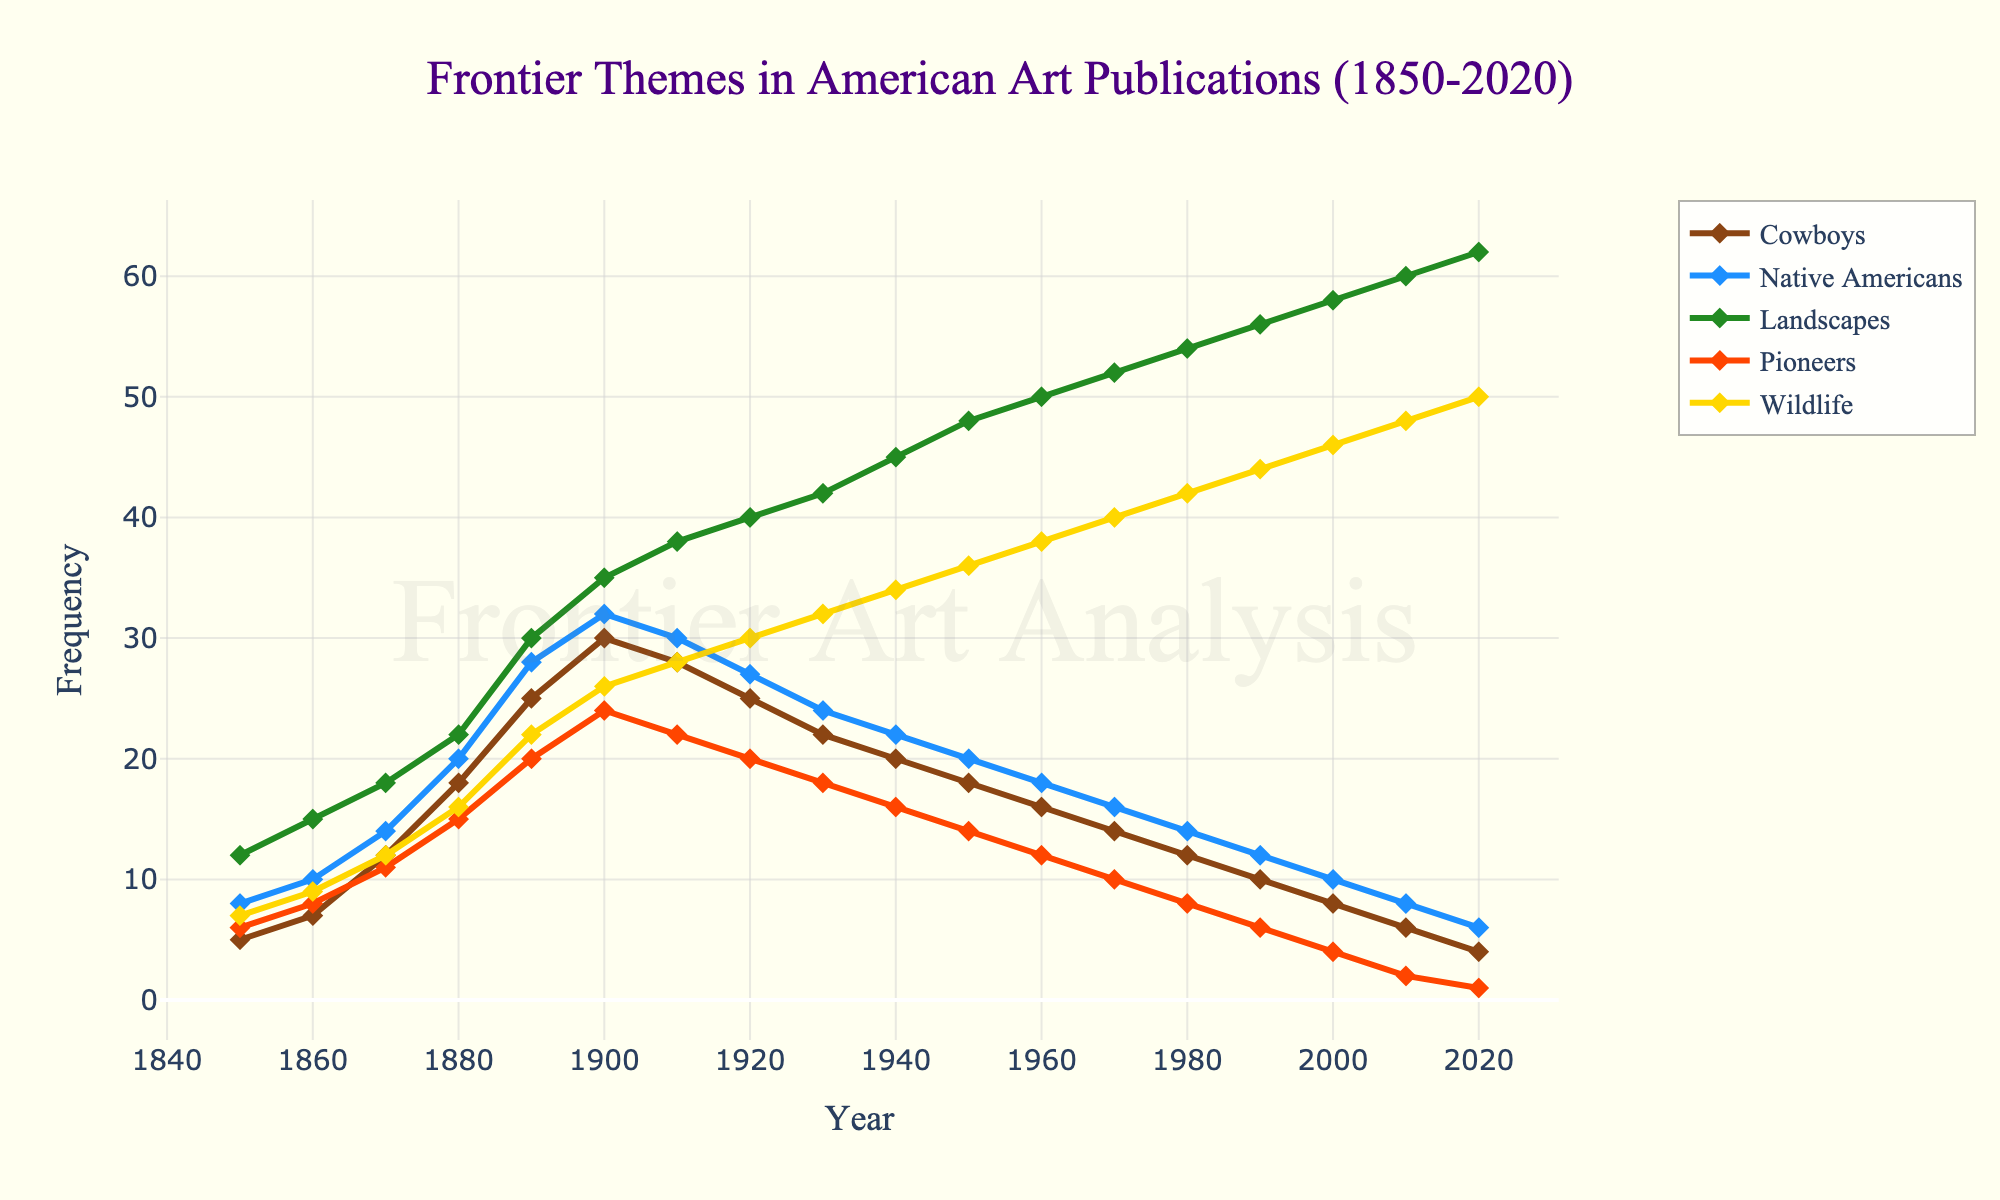Which theme had the highest frequency in 1920? In 1920, the frequency of each theme is represented visually on the line chart by their respective heights. By observing the chart, we can see that "Landscapes" has the highest point in 1920.
Answer: Landscapes How did the frequency of the "Cowboys" theme change from 1850 to 1880? To find the change in frequency, we need to subtract the frequency in 1850 from the frequency in 1880 for the "Cowboys" theme. In 1850, it was 5, and in 1880, it was 18. So, the change is 18 - 5.
Answer: Increase of 13 Which theme showed the most consistent increase over time? By analyzing the slopes of the lines for each theme on the chart, "Landscapes" stands out as the theme with the most consistent and steady increase from 1850 to 2020.
Answer: Landscapes In which decade did the "Native Americans" theme reach its peak frequency? By looking at the highest point on the "Native Americans" line, we see that its peak occurs in the 1900s.
Answer: 1900s Comparing "Pioneers" and "Wildlife" themes, which one had a higher frequency in 1940, and by how much? In 1940, the frequencies are 16 for "Pioneers" and 34 for "Wildlife". The difference is calculated by subtracting 16 from 34.
Answer: Wildlife by 18 What was the average frequency of the "Landscapes" theme across all years? To calculate the average, sum all the values of the "Landscapes" theme and divide by the number of years. Sum: 12 + 15 + 18 + 22 + 30 + 35 + 38 + 40 + 42 + 45 + 48 + 50 + 52 + 54 + 56 + 58 + 60 + 62 = 687. Number of years = 18. Average = 687 / 18
Answer: 38.17 Which theme experienced the largest drop in frequency from one decade to the next? By looking at the data points for each decade, the "Cowboys" theme shows a notable drop from 30 in 1900 to 28 in 1910. However, the most significant single drop appears with "Cowboys" from 1930 to 1940 (22 to 20).
Answer: Cowboys Which theme showed an increasing trend in frequency throughout the entire time span from 1850 to 2020 without any decrease? The "Wildlife" theme shows a continuous and steady increase from 7 in 1850 to 50 in 2020, indicating no periods of decrease.
Answer: Wildlife 